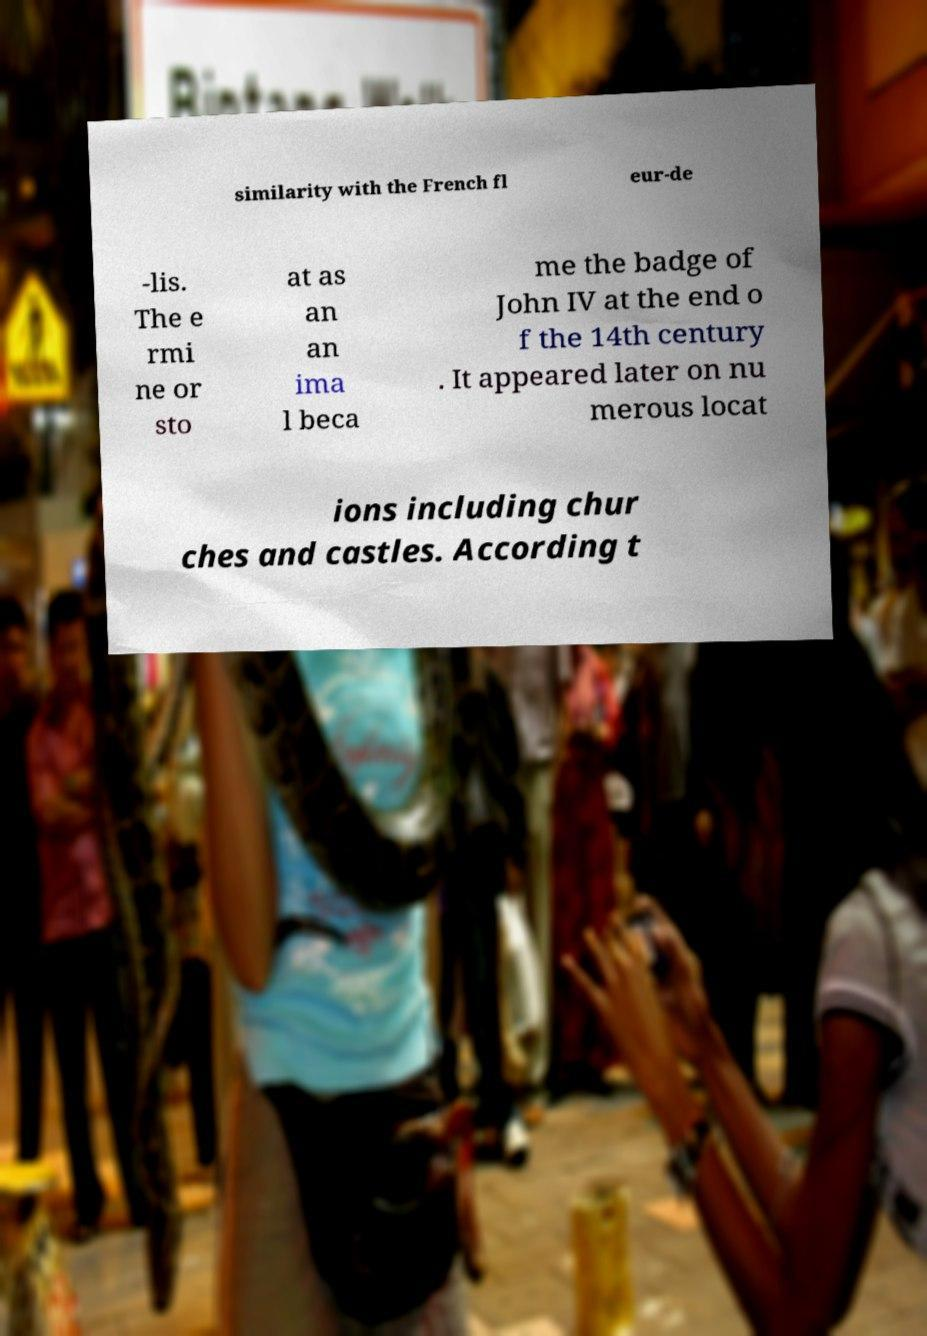Could you extract and type out the text from this image? similarity with the French fl eur-de -lis. The e rmi ne or sto at as an an ima l beca me the badge of John IV at the end o f the 14th century . It appeared later on nu merous locat ions including chur ches and castles. According t 